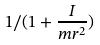Convert formula to latex. <formula><loc_0><loc_0><loc_500><loc_500>1 / ( 1 + \frac { I } { m r ^ { 2 } } )</formula> 